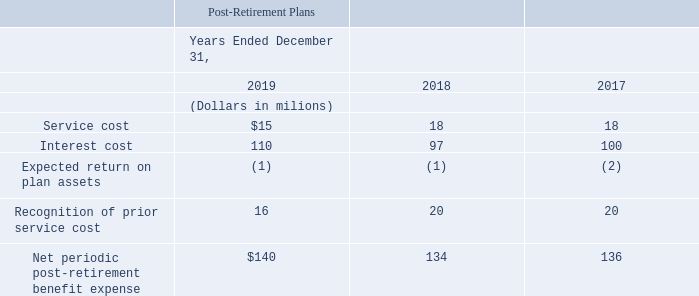Net periodic benefit expense for our post-retirement benefit plans includes the following components:
We report service costs for our Combined Pension Plan and post-retirement benefit plans in cost of services and products and selling, general and administrative expenses in our consolidated statements of operations for the years ended December 31, 2019, 2018 and 2017. Additionally, a portion of the service cost is also allocated to certain assets under construction, which are capitalized and reflected as part of property, plant and equipment in our consolidated balance sheets. The remaining components of net periodic benefit expense (income) are reported in other income, net in our consolidated statements of operations. As a result of ongoing efforts to reduce our workforce, we recognized a one-time charge in 2019 of $6 million and in 2018 of $15 million for special termination benefit enhancements paid to certain eligible employees upon voluntary retirement.
What was recognized as a result of ongoing efforts to reduce the company's workforce? A one-time charge in 2019 of $6 million and in 2018 of $15 million for special termination benefit enhancements paid to certain eligible employees upon voluntary retirement. Where are the remaining components of net periodic benefit expense (income) reported? In other income, net in our consolidated statements of operations. Which are the components included in the net periodic benefit expense for the post-retirement benefit plans? Service cost, interest cost, expected return on plan assets, recognition of prior service cost, net periodic post-retirement benefit expense. How many components are included in the net periodic benefit expense reported for the post-retirement benefit plans? Service cost##interest cost##expected return on plan assets##recognition of prior service cost##net periodic post-retirement benefit expense
answer: 5. What is the sum of service costs in 2017, 2018 and 2019?
Answer scale should be: million. 15+18+18
Answer: 51. What is the average amount of service costs across 2017, 2018 and 2019?
Answer scale should be: million. (15+18+18)/3
Answer: 17. 